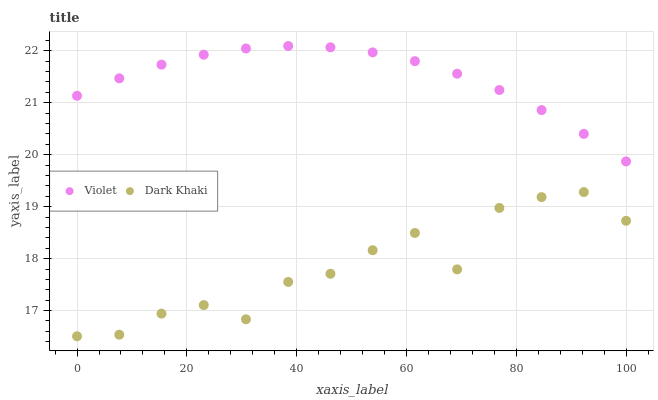Does Dark Khaki have the minimum area under the curve?
Answer yes or no. Yes. Does Violet have the maximum area under the curve?
Answer yes or no. Yes. Does Violet have the minimum area under the curve?
Answer yes or no. No. Is Violet the smoothest?
Answer yes or no. Yes. Is Dark Khaki the roughest?
Answer yes or no. Yes. Is Violet the roughest?
Answer yes or no. No. Does Dark Khaki have the lowest value?
Answer yes or no. Yes. Does Violet have the lowest value?
Answer yes or no. No. Does Violet have the highest value?
Answer yes or no. Yes. Is Dark Khaki less than Violet?
Answer yes or no. Yes. Is Violet greater than Dark Khaki?
Answer yes or no. Yes. Does Dark Khaki intersect Violet?
Answer yes or no. No. 